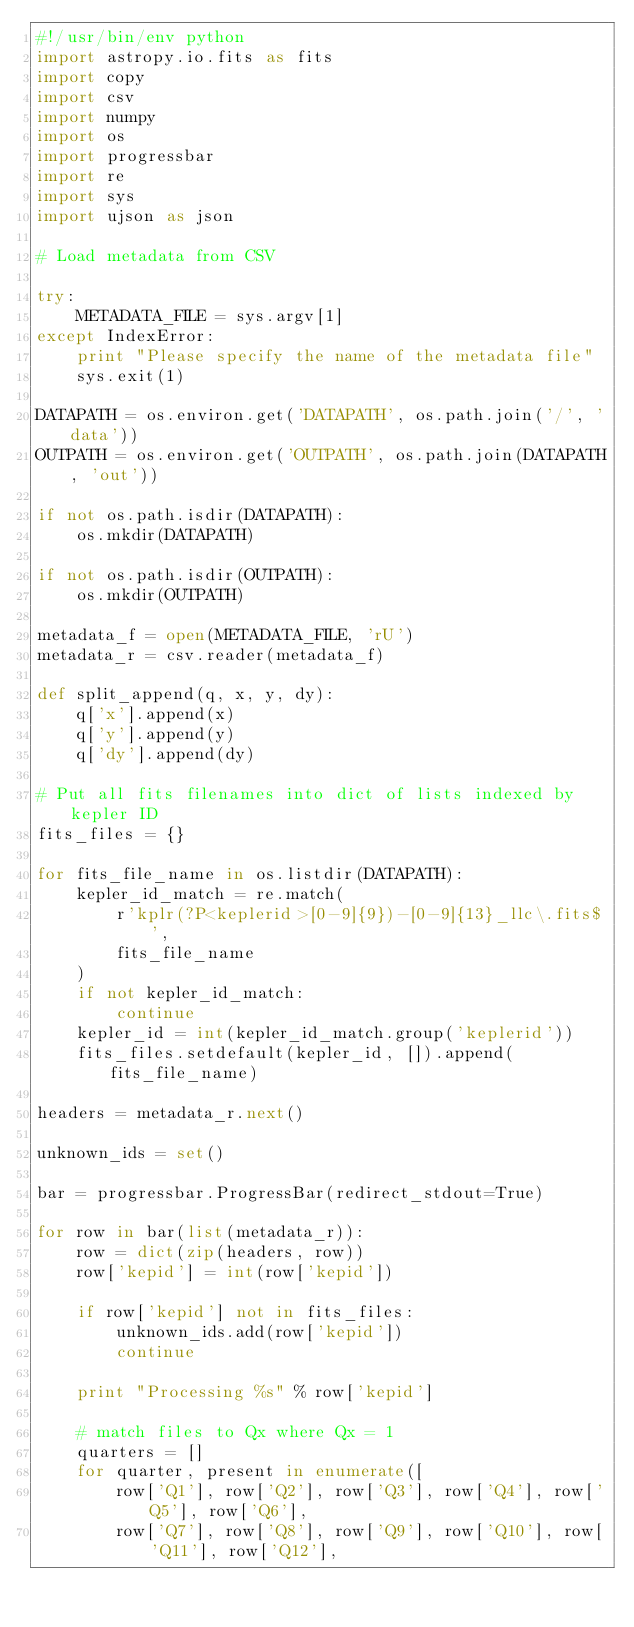Convert code to text. <code><loc_0><loc_0><loc_500><loc_500><_Python_>#!/usr/bin/env python
import astropy.io.fits as fits
import copy
import csv
import numpy
import os
import progressbar
import re
import sys
import ujson as json

# Load metadata from CSV

try:
    METADATA_FILE = sys.argv[1]
except IndexError:
    print "Please specify the name of the metadata file"
    sys.exit(1)

DATAPATH = os.environ.get('DATAPATH', os.path.join('/', 'data'))
OUTPATH = os.environ.get('OUTPATH', os.path.join(DATAPATH, 'out'))

if not os.path.isdir(DATAPATH):
    os.mkdir(DATAPATH)

if not os.path.isdir(OUTPATH):
    os.mkdir(OUTPATH)

metadata_f = open(METADATA_FILE, 'rU')
metadata_r = csv.reader(metadata_f)

def split_append(q, x, y, dy):
    q['x'].append(x)
    q['y'].append(y)
    q['dy'].append(dy)

# Put all fits filenames into dict of lists indexed by kepler ID
fits_files = {}

for fits_file_name in os.listdir(DATAPATH):
    kepler_id_match = re.match(
        r'kplr(?P<keplerid>[0-9]{9})-[0-9]{13}_llc\.fits$',
        fits_file_name
    )
    if not kepler_id_match:
        continue
    kepler_id = int(kepler_id_match.group('keplerid'))
    fits_files.setdefault(kepler_id, []).append(fits_file_name)

headers = metadata_r.next()

unknown_ids = set()

bar = progressbar.ProgressBar(redirect_stdout=True)

for row in bar(list(metadata_r)):
    row = dict(zip(headers, row))
    row['kepid'] = int(row['kepid'])

    if row['kepid'] not in fits_files:
        unknown_ids.add(row['kepid'])
        continue

    print "Processing %s" % row['kepid']

    # match files to Qx where Qx = 1
    quarters = []
    for quarter, present in enumerate([
        row['Q1'], row['Q2'], row['Q3'], row['Q4'], row['Q5'], row['Q6'],
        row['Q7'], row['Q8'], row['Q9'], row['Q10'], row['Q11'], row['Q12'],</code> 